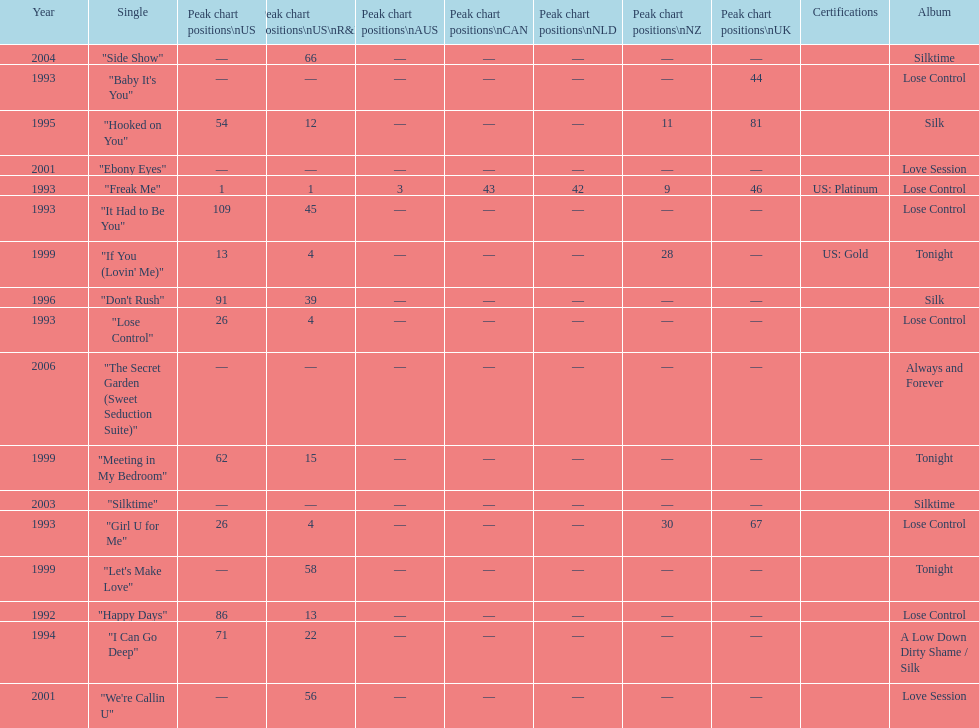Which single is the most in terms of how many times it charted? "Freak Me". 